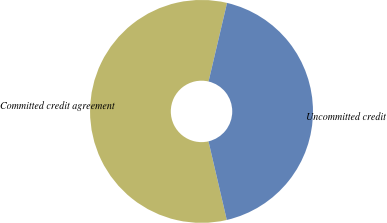Convert chart to OTSL. <chart><loc_0><loc_0><loc_500><loc_500><pie_chart><fcel>Committed credit agreement<fcel>Uncommitted credit<nl><fcel>57.32%<fcel>42.68%<nl></chart> 